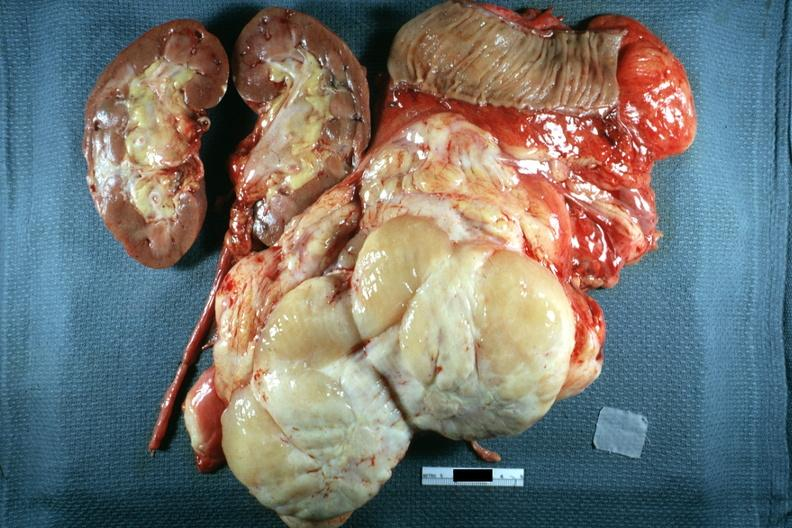what does this image show?
Answer the question using a single word or phrase. Nodular tumor sectioned to show cut surface kidney portion of jejunum shown in surgically resected specimen excellent 